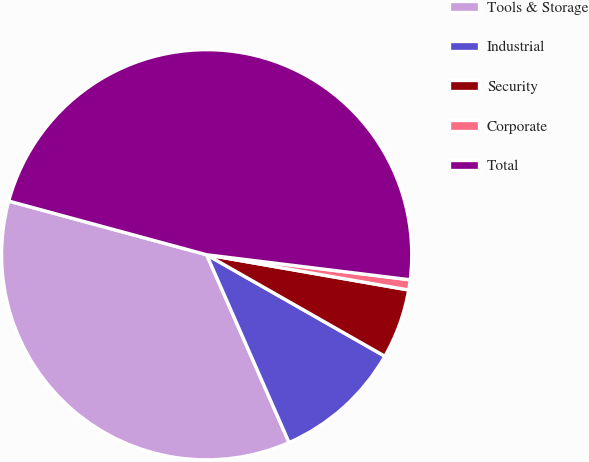Convert chart to OTSL. <chart><loc_0><loc_0><loc_500><loc_500><pie_chart><fcel>Tools & Storage<fcel>Industrial<fcel>Security<fcel>Corporate<fcel>Total<nl><fcel>35.8%<fcel>10.18%<fcel>5.49%<fcel>0.8%<fcel>47.73%<nl></chart> 